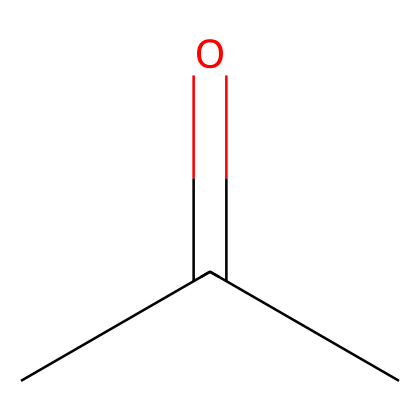What is the molecular formula of acetone? By analyzing the structure provided in the SMILES notation, we can identify that acetone contains three carbon atoms (C), six hydrogen atoms (H), and one oxygen atom (O). Therefore, the molecular formula is C3H6O.
Answer: C3H6O How many carbon atoms are in acetone? The SMILES representation shows "CC(=O)C" indicating three carbon atoms are connected. We can see two carbon atoms are in the chain and one is attached to the carbonyl group, making a total of three.
Answer: 3 What type of functional group is present in acetone? The structure includes a carbonyl group (C=O) connected to two carbon atoms, which is characteristic of ketones. Therefore, the functional group present here is a carbonyl group.
Answer: carbonyl How many hydrogen atoms are attached to the carbonyl carbon in acetone? The carbonyl carbon (C=O) does not have any hydrogen atoms attached to it because it is fully bonded to an oxygen atom. Hence, the number of hydrogen atoms attached to this carbon is zero.
Answer: 0 What happens to acetone when it evaporates? Acetone, being a volatile liquid, converts from liquid to vapor state upon heating or at room temperature due to its relatively low boiling point (~56°C). This property highlights its use in nail polish remover.
Answer: evaporates What is the common use of acetone in households? Acetone is widely recognized for its application as a solvent in nail polish remover, making it a common household item, especially for cosmetic purposes.
Answer: nail polish remover 